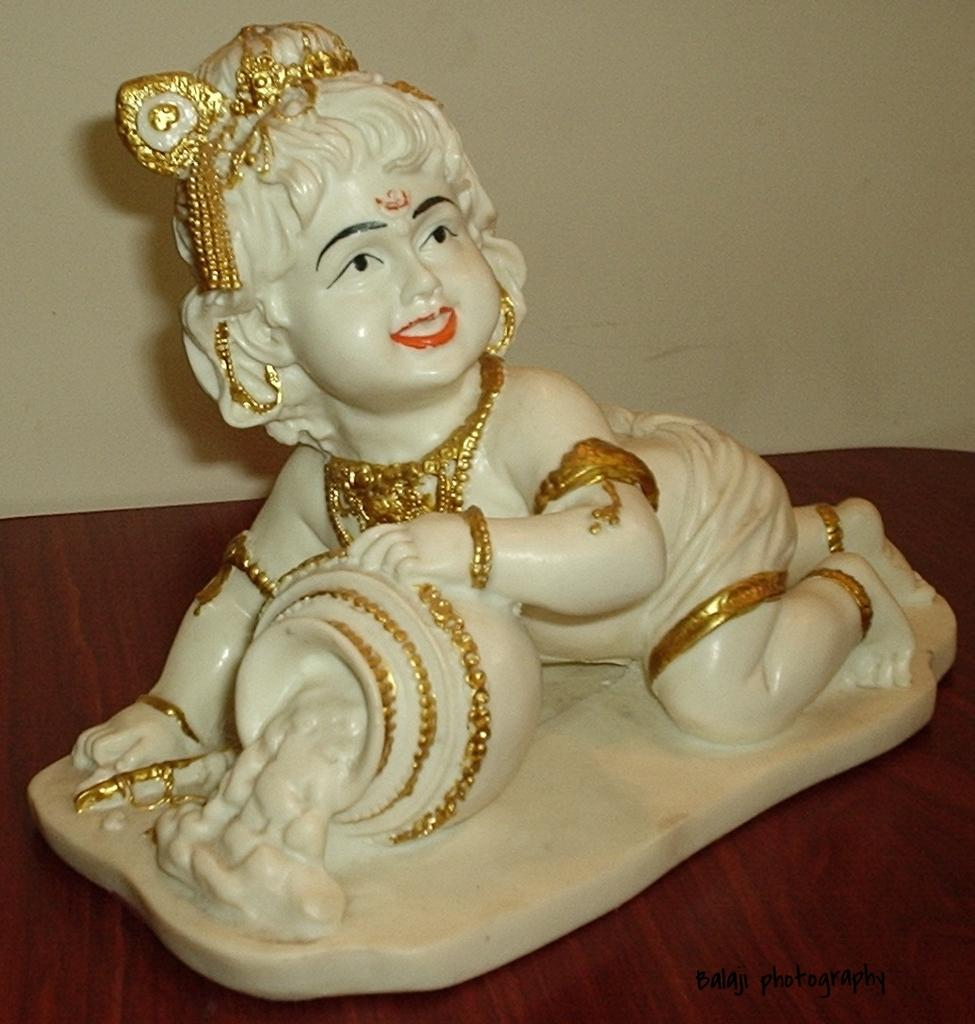What is the main subject of the picture? There is a white idol statue in the picture. Where is the statue located? The statue is kept on a table. What can be seen in the background of the picture? There is a wall visible in the background of the picture. What emotion does the statue express towards the marble in the image? There is no marble present in the image, and the statue is an inanimate object, so it cannot express emotions. 